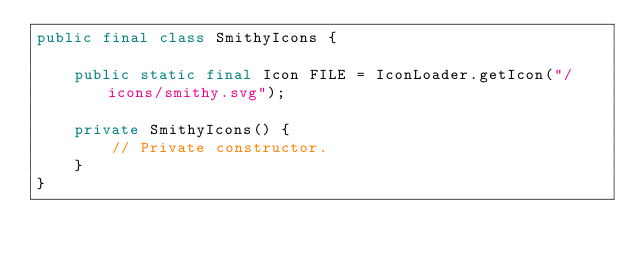Convert code to text. <code><loc_0><loc_0><loc_500><loc_500><_Java_>public final class SmithyIcons {

    public static final Icon FILE = IconLoader.getIcon("/icons/smithy.svg");

    private SmithyIcons() {
        // Private constructor.
    }
}
</code> 